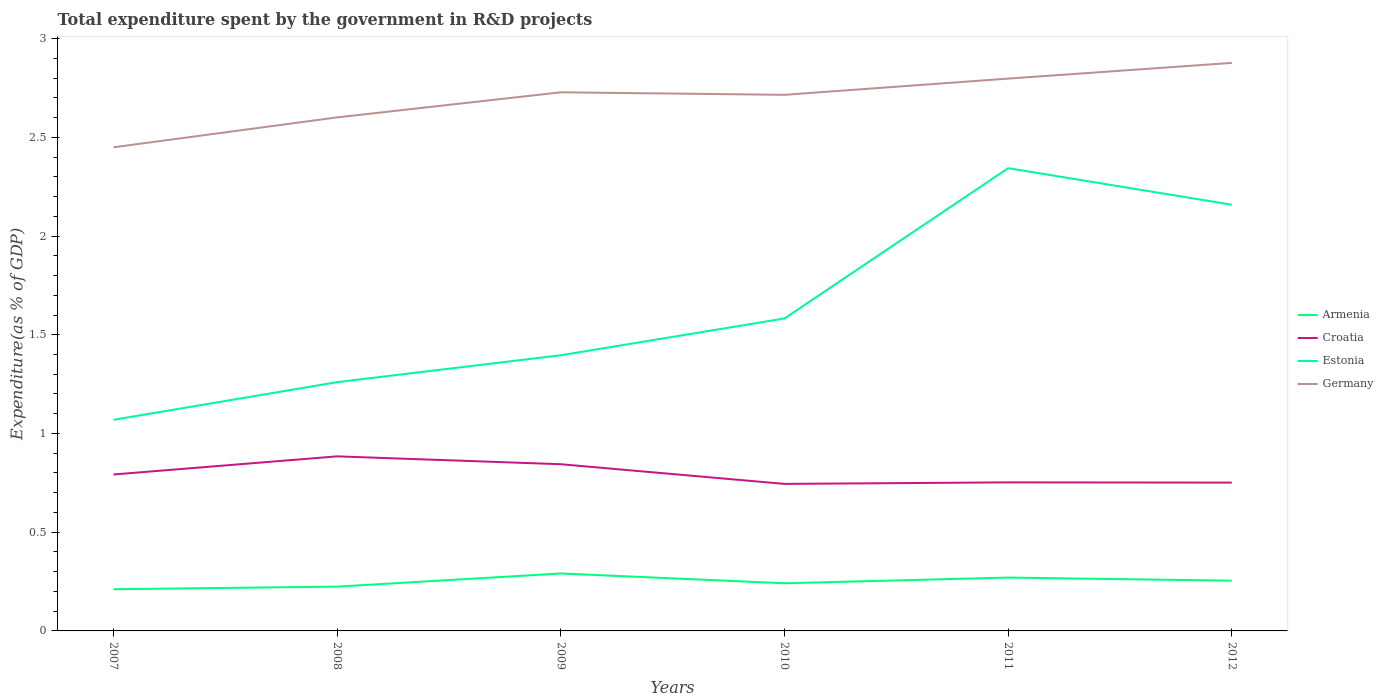Across all years, what is the maximum total expenditure spent by the government in R&D projects in Germany?
Make the answer very short. 2.45. What is the total total expenditure spent by the government in R&D projects in Croatia in the graph?
Your response must be concise. 0.04. What is the difference between the highest and the second highest total expenditure spent by the government in R&D projects in Germany?
Your answer should be very brief. 0.43. What is the difference between the highest and the lowest total expenditure spent by the government in R&D projects in Estonia?
Your answer should be very brief. 2. Is the total expenditure spent by the government in R&D projects in Germany strictly greater than the total expenditure spent by the government in R&D projects in Croatia over the years?
Give a very brief answer. No. How many lines are there?
Ensure brevity in your answer.  4. How many years are there in the graph?
Give a very brief answer. 6. Does the graph contain any zero values?
Your response must be concise. No. How many legend labels are there?
Offer a terse response. 4. How are the legend labels stacked?
Keep it short and to the point. Vertical. What is the title of the graph?
Offer a very short reply. Total expenditure spent by the government in R&D projects. Does "Palau" appear as one of the legend labels in the graph?
Provide a succinct answer. No. What is the label or title of the X-axis?
Make the answer very short. Years. What is the label or title of the Y-axis?
Provide a succinct answer. Expenditure(as % of GDP). What is the Expenditure(as % of GDP) of Armenia in 2007?
Your answer should be compact. 0.21. What is the Expenditure(as % of GDP) of Croatia in 2007?
Provide a short and direct response. 0.79. What is the Expenditure(as % of GDP) in Estonia in 2007?
Provide a succinct answer. 1.07. What is the Expenditure(as % of GDP) in Germany in 2007?
Your answer should be very brief. 2.45. What is the Expenditure(as % of GDP) of Armenia in 2008?
Ensure brevity in your answer.  0.22. What is the Expenditure(as % of GDP) of Croatia in 2008?
Make the answer very short. 0.88. What is the Expenditure(as % of GDP) of Estonia in 2008?
Your response must be concise. 1.26. What is the Expenditure(as % of GDP) of Germany in 2008?
Give a very brief answer. 2.6. What is the Expenditure(as % of GDP) in Armenia in 2009?
Your response must be concise. 0.29. What is the Expenditure(as % of GDP) of Croatia in 2009?
Your response must be concise. 0.84. What is the Expenditure(as % of GDP) of Estonia in 2009?
Provide a short and direct response. 1.4. What is the Expenditure(as % of GDP) in Germany in 2009?
Offer a terse response. 2.73. What is the Expenditure(as % of GDP) in Armenia in 2010?
Offer a terse response. 0.24. What is the Expenditure(as % of GDP) in Croatia in 2010?
Your response must be concise. 0.74. What is the Expenditure(as % of GDP) of Estonia in 2010?
Offer a very short reply. 1.58. What is the Expenditure(as % of GDP) in Germany in 2010?
Keep it short and to the point. 2.72. What is the Expenditure(as % of GDP) of Armenia in 2011?
Ensure brevity in your answer.  0.27. What is the Expenditure(as % of GDP) in Croatia in 2011?
Your answer should be very brief. 0.75. What is the Expenditure(as % of GDP) in Estonia in 2011?
Your answer should be compact. 2.34. What is the Expenditure(as % of GDP) of Germany in 2011?
Your answer should be compact. 2.8. What is the Expenditure(as % of GDP) of Armenia in 2012?
Your answer should be compact. 0.25. What is the Expenditure(as % of GDP) of Croatia in 2012?
Ensure brevity in your answer.  0.75. What is the Expenditure(as % of GDP) of Estonia in 2012?
Your answer should be compact. 2.16. What is the Expenditure(as % of GDP) of Germany in 2012?
Keep it short and to the point. 2.88. Across all years, what is the maximum Expenditure(as % of GDP) of Armenia?
Your response must be concise. 0.29. Across all years, what is the maximum Expenditure(as % of GDP) of Croatia?
Your answer should be very brief. 0.88. Across all years, what is the maximum Expenditure(as % of GDP) in Estonia?
Offer a terse response. 2.34. Across all years, what is the maximum Expenditure(as % of GDP) of Germany?
Ensure brevity in your answer.  2.88. Across all years, what is the minimum Expenditure(as % of GDP) of Armenia?
Provide a short and direct response. 0.21. Across all years, what is the minimum Expenditure(as % of GDP) of Croatia?
Provide a succinct answer. 0.74. Across all years, what is the minimum Expenditure(as % of GDP) in Estonia?
Provide a succinct answer. 1.07. Across all years, what is the minimum Expenditure(as % of GDP) of Germany?
Provide a succinct answer. 2.45. What is the total Expenditure(as % of GDP) of Armenia in the graph?
Provide a short and direct response. 1.49. What is the total Expenditure(as % of GDP) in Croatia in the graph?
Your answer should be very brief. 4.77. What is the total Expenditure(as % of GDP) in Estonia in the graph?
Provide a short and direct response. 9.81. What is the total Expenditure(as % of GDP) of Germany in the graph?
Provide a short and direct response. 16.17. What is the difference between the Expenditure(as % of GDP) in Armenia in 2007 and that in 2008?
Offer a very short reply. -0.01. What is the difference between the Expenditure(as % of GDP) of Croatia in 2007 and that in 2008?
Make the answer very short. -0.09. What is the difference between the Expenditure(as % of GDP) of Estonia in 2007 and that in 2008?
Provide a succinct answer. -0.19. What is the difference between the Expenditure(as % of GDP) of Germany in 2007 and that in 2008?
Your answer should be very brief. -0.15. What is the difference between the Expenditure(as % of GDP) in Armenia in 2007 and that in 2009?
Offer a very short reply. -0.08. What is the difference between the Expenditure(as % of GDP) in Croatia in 2007 and that in 2009?
Offer a terse response. -0.05. What is the difference between the Expenditure(as % of GDP) in Estonia in 2007 and that in 2009?
Provide a succinct answer. -0.33. What is the difference between the Expenditure(as % of GDP) in Germany in 2007 and that in 2009?
Offer a very short reply. -0.28. What is the difference between the Expenditure(as % of GDP) of Armenia in 2007 and that in 2010?
Provide a short and direct response. -0.03. What is the difference between the Expenditure(as % of GDP) of Croatia in 2007 and that in 2010?
Your answer should be compact. 0.05. What is the difference between the Expenditure(as % of GDP) of Estonia in 2007 and that in 2010?
Offer a terse response. -0.51. What is the difference between the Expenditure(as % of GDP) in Germany in 2007 and that in 2010?
Your answer should be compact. -0.27. What is the difference between the Expenditure(as % of GDP) in Armenia in 2007 and that in 2011?
Give a very brief answer. -0.06. What is the difference between the Expenditure(as % of GDP) in Croatia in 2007 and that in 2011?
Your answer should be very brief. 0.04. What is the difference between the Expenditure(as % of GDP) in Estonia in 2007 and that in 2011?
Provide a succinct answer. -1.27. What is the difference between the Expenditure(as % of GDP) of Germany in 2007 and that in 2011?
Your answer should be compact. -0.35. What is the difference between the Expenditure(as % of GDP) of Armenia in 2007 and that in 2012?
Your response must be concise. -0.04. What is the difference between the Expenditure(as % of GDP) of Croatia in 2007 and that in 2012?
Make the answer very short. 0.04. What is the difference between the Expenditure(as % of GDP) of Estonia in 2007 and that in 2012?
Make the answer very short. -1.09. What is the difference between the Expenditure(as % of GDP) in Germany in 2007 and that in 2012?
Your answer should be compact. -0.43. What is the difference between the Expenditure(as % of GDP) in Armenia in 2008 and that in 2009?
Offer a terse response. -0.07. What is the difference between the Expenditure(as % of GDP) in Croatia in 2008 and that in 2009?
Keep it short and to the point. 0.04. What is the difference between the Expenditure(as % of GDP) in Estonia in 2008 and that in 2009?
Provide a short and direct response. -0.14. What is the difference between the Expenditure(as % of GDP) in Germany in 2008 and that in 2009?
Give a very brief answer. -0.13. What is the difference between the Expenditure(as % of GDP) in Armenia in 2008 and that in 2010?
Give a very brief answer. -0.02. What is the difference between the Expenditure(as % of GDP) in Croatia in 2008 and that in 2010?
Provide a succinct answer. 0.14. What is the difference between the Expenditure(as % of GDP) of Estonia in 2008 and that in 2010?
Provide a short and direct response. -0.32. What is the difference between the Expenditure(as % of GDP) in Germany in 2008 and that in 2010?
Provide a short and direct response. -0.11. What is the difference between the Expenditure(as % of GDP) of Armenia in 2008 and that in 2011?
Your answer should be compact. -0.05. What is the difference between the Expenditure(as % of GDP) in Croatia in 2008 and that in 2011?
Keep it short and to the point. 0.13. What is the difference between the Expenditure(as % of GDP) in Estonia in 2008 and that in 2011?
Give a very brief answer. -1.08. What is the difference between the Expenditure(as % of GDP) in Germany in 2008 and that in 2011?
Your answer should be very brief. -0.2. What is the difference between the Expenditure(as % of GDP) in Armenia in 2008 and that in 2012?
Offer a very short reply. -0.03. What is the difference between the Expenditure(as % of GDP) of Croatia in 2008 and that in 2012?
Provide a short and direct response. 0.13. What is the difference between the Expenditure(as % of GDP) in Estonia in 2008 and that in 2012?
Give a very brief answer. -0.9. What is the difference between the Expenditure(as % of GDP) in Germany in 2008 and that in 2012?
Your answer should be very brief. -0.28. What is the difference between the Expenditure(as % of GDP) in Armenia in 2009 and that in 2010?
Provide a succinct answer. 0.05. What is the difference between the Expenditure(as % of GDP) in Croatia in 2009 and that in 2010?
Make the answer very short. 0.1. What is the difference between the Expenditure(as % of GDP) of Estonia in 2009 and that in 2010?
Make the answer very short. -0.19. What is the difference between the Expenditure(as % of GDP) of Germany in 2009 and that in 2010?
Give a very brief answer. 0.01. What is the difference between the Expenditure(as % of GDP) of Armenia in 2009 and that in 2011?
Your answer should be compact. 0.02. What is the difference between the Expenditure(as % of GDP) in Croatia in 2009 and that in 2011?
Offer a very short reply. 0.09. What is the difference between the Expenditure(as % of GDP) in Estonia in 2009 and that in 2011?
Your answer should be very brief. -0.95. What is the difference between the Expenditure(as % of GDP) in Germany in 2009 and that in 2011?
Your answer should be compact. -0.07. What is the difference between the Expenditure(as % of GDP) in Armenia in 2009 and that in 2012?
Provide a short and direct response. 0.04. What is the difference between the Expenditure(as % of GDP) in Croatia in 2009 and that in 2012?
Your answer should be compact. 0.09. What is the difference between the Expenditure(as % of GDP) in Estonia in 2009 and that in 2012?
Offer a very short reply. -0.76. What is the difference between the Expenditure(as % of GDP) in Germany in 2009 and that in 2012?
Make the answer very short. -0.15. What is the difference between the Expenditure(as % of GDP) of Armenia in 2010 and that in 2011?
Give a very brief answer. -0.03. What is the difference between the Expenditure(as % of GDP) of Croatia in 2010 and that in 2011?
Provide a short and direct response. -0.01. What is the difference between the Expenditure(as % of GDP) of Estonia in 2010 and that in 2011?
Your answer should be very brief. -0.76. What is the difference between the Expenditure(as % of GDP) of Germany in 2010 and that in 2011?
Offer a very short reply. -0.08. What is the difference between the Expenditure(as % of GDP) of Armenia in 2010 and that in 2012?
Provide a succinct answer. -0.01. What is the difference between the Expenditure(as % of GDP) in Croatia in 2010 and that in 2012?
Your answer should be very brief. -0.01. What is the difference between the Expenditure(as % of GDP) in Estonia in 2010 and that in 2012?
Provide a succinct answer. -0.58. What is the difference between the Expenditure(as % of GDP) of Germany in 2010 and that in 2012?
Keep it short and to the point. -0.16. What is the difference between the Expenditure(as % of GDP) of Armenia in 2011 and that in 2012?
Ensure brevity in your answer.  0.02. What is the difference between the Expenditure(as % of GDP) in Croatia in 2011 and that in 2012?
Keep it short and to the point. 0. What is the difference between the Expenditure(as % of GDP) in Estonia in 2011 and that in 2012?
Offer a very short reply. 0.19. What is the difference between the Expenditure(as % of GDP) of Germany in 2011 and that in 2012?
Your answer should be compact. -0.08. What is the difference between the Expenditure(as % of GDP) of Armenia in 2007 and the Expenditure(as % of GDP) of Croatia in 2008?
Make the answer very short. -0.67. What is the difference between the Expenditure(as % of GDP) in Armenia in 2007 and the Expenditure(as % of GDP) in Estonia in 2008?
Your response must be concise. -1.05. What is the difference between the Expenditure(as % of GDP) of Armenia in 2007 and the Expenditure(as % of GDP) of Germany in 2008?
Your answer should be very brief. -2.39. What is the difference between the Expenditure(as % of GDP) in Croatia in 2007 and the Expenditure(as % of GDP) in Estonia in 2008?
Offer a very short reply. -0.47. What is the difference between the Expenditure(as % of GDP) in Croatia in 2007 and the Expenditure(as % of GDP) in Germany in 2008?
Offer a very short reply. -1.81. What is the difference between the Expenditure(as % of GDP) in Estonia in 2007 and the Expenditure(as % of GDP) in Germany in 2008?
Your answer should be compact. -1.53. What is the difference between the Expenditure(as % of GDP) in Armenia in 2007 and the Expenditure(as % of GDP) in Croatia in 2009?
Offer a terse response. -0.63. What is the difference between the Expenditure(as % of GDP) in Armenia in 2007 and the Expenditure(as % of GDP) in Estonia in 2009?
Offer a very short reply. -1.19. What is the difference between the Expenditure(as % of GDP) of Armenia in 2007 and the Expenditure(as % of GDP) of Germany in 2009?
Provide a succinct answer. -2.52. What is the difference between the Expenditure(as % of GDP) in Croatia in 2007 and the Expenditure(as % of GDP) in Estonia in 2009?
Your response must be concise. -0.6. What is the difference between the Expenditure(as % of GDP) in Croatia in 2007 and the Expenditure(as % of GDP) in Germany in 2009?
Make the answer very short. -1.94. What is the difference between the Expenditure(as % of GDP) of Estonia in 2007 and the Expenditure(as % of GDP) of Germany in 2009?
Your answer should be very brief. -1.66. What is the difference between the Expenditure(as % of GDP) of Armenia in 2007 and the Expenditure(as % of GDP) of Croatia in 2010?
Your answer should be compact. -0.53. What is the difference between the Expenditure(as % of GDP) of Armenia in 2007 and the Expenditure(as % of GDP) of Estonia in 2010?
Your answer should be very brief. -1.37. What is the difference between the Expenditure(as % of GDP) in Armenia in 2007 and the Expenditure(as % of GDP) in Germany in 2010?
Make the answer very short. -2.5. What is the difference between the Expenditure(as % of GDP) in Croatia in 2007 and the Expenditure(as % of GDP) in Estonia in 2010?
Your answer should be compact. -0.79. What is the difference between the Expenditure(as % of GDP) in Croatia in 2007 and the Expenditure(as % of GDP) in Germany in 2010?
Your answer should be very brief. -1.92. What is the difference between the Expenditure(as % of GDP) of Estonia in 2007 and the Expenditure(as % of GDP) of Germany in 2010?
Offer a very short reply. -1.65. What is the difference between the Expenditure(as % of GDP) of Armenia in 2007 and the Expenditure(as % of GDP) of Croatia in 2011?
Provide a succinct answer. -0.54. What is the difference between the Expenditure(as % of GDP) in Armenia in 2007 and the Expenditure(as % of GDP) in Estonia in 2011?
Your answer should be compact. -2.13. What is the difference between the Expenditure(as % of GDP) of Armenia in 2007 and the Expenditure(as % of GDP) of Germany in 2011?
Your response must be concise. -2.59. What is the difference between the Expenditure(as % of GDP) in Croatia in 2007 and the Expenditure(as % of GDP) in Estonia in 2011?
Give a very brief answer. -1.55. What is the difference between the Expenditure(as % of GDP) in Croatia in 2007 and the Expenditure(as % of GDP) in Germany in 2011?
Provide a short and direct response. -2. What is the difference between the Expenditure(as % of GDP) in Estonia in 2007 and the Expenditure(as % of GDP) in Germany in 2011?
Offer a terse response. -1.73. What is the difference between the Expenditure(as % of GDP) in Armenia in 2007 and the Expenditure(as % of GDP) in Croatia in 2012?
Your answer should be compact. -0.54. What is the difference between the Expenditure(as % of GDP) in Armenia in 2007 and the Expenditure(as % of GDP) in Estonia in 2012?
Give a very brief answer. -1.95. What is the difference between the Expenditure(as % of GDP) in Armenia in 2007 and the Expenditure(as % of GDP) in Germany in 2012?
Give a very brief answer. -2.67. What is the difference between the Expenditure(as % of GDP) of Croatia in 2007 and the Expenditure(as % of GDP) of Estonia in 2012?
Your response must be concise. -1.37. What is the difference between the Expenditure(as % of GDP) in Croatia in 2007 and the Expenditure(as % of GDP) in Germany in 2012?
Keep it short and to the point. -2.08. What is the difference between the Expenditure(as % of GDP) in Estonia in 2007 and the Expenditure(as % of GDP) in Germany in 2012?
Offer a very short reply. -1.81. What is the difference between the Expenditure(as % of GDP) of Armenia in 2008 and the Expenditure(as % of GDP) of Croatia in 2009?
Keep it short and to the point. -0.62. What is the difference between the Expenditure(as % of GDP) of Armenia in 2008 and the Expenditure(as % of GDP) of Estonia in 2009?
Keep it short and to the point. -1.17. What is the difference between the Expenditure(as % of GDP) in Armenia in 2008 and the Expenditure(as % of GDP) in Germany in 2009?
Offer a terse response. -2.5. What is the difference between the Expenditure(as % of GDP) in Croatia in 2008 and the Expenditure(as % of GDP) in Estonia in 2009?
Provide a short and direct response. -0.51. What is the difference between the Expenditure(as % of GDP) in Croatia in 2008 and the Expenditure(as % of GDP) in Germany in 2009?
Make the answer very short. -1.84. What is the difference between the Expenditure(as % of GDP) in Estonia in 2008 and the Expenditure(as % of GDP) in Germany in 2009?
Your answer should be very brief. -1.47. What is the difference between the Expenditure(as % of GDP) in Armenia in 2008 and the Expenditure(as % of GDP) in Croatia in 2010?
Offer a very short reply. -0.52. What is the difference between the Expenditure(as % of GDP) of Armenia in 2008 and the Expenditure(as % of GDP) of Estonia in 2010?
Give a very brief answer. -1.36. What is the difference between the Expenditure(as % of GDP) of Armenia in 2008 and the Expenditure(as % of GDP) of Germany in 2010?
Keep it short and to the point. -2.49. What is the difference between the Expenditure(as % of GDP) in Croatia in 2008 and the Expenditure(as % of GDP) in Estonia in 2010?
Ensure brevity in your answer.  -0.7. What is the difference between the Expenditure(as % of GDP) of Croatia in 2008 and the Expenditure(as % of GDP) of Germany in 2010?
Ensure brevity in your answer.  -1.83. What is the difference between the Expenditure(as % of GDP) in Estonia in 2008 and the Expenditure(as % of GDP) in Germany in 2010?
Ensure brevity in your answer.  -1.46. What is the difference between the Expenditure(as % of GDP) in Armenia in 2008 and the Expenditure(as % of GDP) in Croatia in 2011?
Offer a terse response. -0.53. What is the difference between the Expenditure(as % of GDP) in Armenia in 2008 and the Expenditure(as % of GDP) in Estonia in 2011?
Keep it short and to the point. -2.12. What is the difference between the Expenditure(as % of GDP) in Armenia in 2008 and the Expenditure(as % of GDP) in Germany in 2011?
Make the answer very short. -2.57. What is the difference between the Expenditure(as % of GDP) of Croatia in 2008 and the Expenditure(as % of GDP) of Estonia in 2011?
Offer a very short reply. -1.46. What is the difference between the Expenditure(as % of GDP) of Croatia in 2008 and the Expenditure(as % of GDP) of Germany in 2011?
Your response must be concise. -1.91. What is the difference between the Expenditure(as % of GDP) in Estonia in 2008 and the Expenditure(as % of GDP) in Germany in 2011?
Offer a terse response. -1.54. What is the difference between the Expenditure(as % of GDP) in Armenia in 2008 and the Expenditure(as % of GDP) in Croatia in 2012?
Provide a succinct answer. -0.53. What is the difference between the Expenditure(as % of GDP) of Armenia in 2008 and the Expenditure(as % of GDP) of Estonia in 2012?
Your response must be concise. -1.93. What is the difference between the Expenditure(as % of GDP) in Armenia in 2008 and the Expenditure(as % of GDP) in Germany in 2012?
Ensure brevity in your answer.  -2.65. What is the difference between the Expenditure(as % of GDP) in Croatia in 2008 and the Expenditure(as % of GDP) in Estonia in 2012?
Make the answer very short. -1.27. What is the difference between the Expenditure(as % of GDP) of Croatia in 2008 and the Expenditure(as % of GDP) of Germany in 2012?
Offer a terse response. -1.99. What is the difference between the Expenditure(as % of GDP) in Estonia in 2008 and the Expenditure(as % of GDP) in Germany in 2012?
Provide a short and direct response. -1.62. What is the difference between the Expenditure(as % of GDP) of Armenia in 2009 and the Expenditure(as % of GDP) of Croatia in 2010?
Provide a short and direct response. -0.45. What is the difference between the Expenditure(as % of GDP) in Armenia in 2009 and the Expenditure(as % of GDP) in Estonia in 2010?
Keep it short and to the point. -1.29. What is the difference between the Expenditure(as % of GDP) of Armenia in 2009 and the Expenditure(as % of GDP) of Germany in 2010?
Provide a succinct answer. -2.42. What is the difference between the Expenditure(as % of GDP) in Croatia in 2009 and the Expenditure(as % of GDP) in Estonia in 2010?
Your answer should be compact. -0.74. What is the difference between the Expenditure(as % of GDP) of Croatia in 2009 and the Expenditure(as % of GDP) of Germany in 2010?
Your answer should be compact. -1.87. What is the difference between the Expenditure(as % of GDP) of Estonia in 2009 and the Expenditure(as % of GDP) of Germany in 2010?
Offer a terse response. -1.32. What is the difference between the Expenditure(as % of GDP) of Armenia in 2009 and the Expenditure(as % of GDP) of Croatia in 2011?
Provide a short and direct response. -0.46. What is the difference between the Expenditure(as % of GDP) in Armenia in 2009 and the Expenditure(as % of GDP) in Estonia in 2011?
Make the answer very short. -2.05. What is the difference between the Expenditure(as % of GDP) in Armenia in 2009 and the Expenditure(as % of GDP) in Germany in 2011?
Make the answer very short. -2.51. What is the difference between the Expenditure(as % of GDP) in Croatia in 2009 and the Expenditure(as % of GDP) in Estonia in 2011?
Ensure brevity in your answer.  -1.5. What is the difference between the Expenditure(as % of GDP) in Croatia in 2009 and the Expenditure(as % of GDP) in Germany in 2011?
Your answer should be compact. -1.95. What is the difference between the Expenditure(as % of GDP) in Estonia in 2009 and the Expenditure(as % of GDP) in Germany in 2011?
Make the answer very short. -1.4. What is the difference between the Expenditure(as % of GDP) in Armenia in 2009 and the Expenditure(as % of GDP) in Croatia in 2012?
Offer a very short reply. -0.46. What is the difference between the Expenditure(as % of GDP) in Armenia in 2009 and the Expenditure(as % of GDP) in Estonia in 2012?
Give a very brief answer. -1.87. What is the difference between the Expenditure(as % of GDP) in Armenia in 2009 and the Expenditure(as % of GDP) in Germany in 2012?
Your answer should be very brief. -2.59. What is the difference between the Expenditure(as % of GDP) in Croatia in 2009 and the Expenditure(as % of GDP) in Estonia in 2012?
Make the answer very short. -1.31. What is the difference between the Expenditure(as % of GDP) in Croatia in 2009 and the Expenditure(as % of GDP) in Germany in 2012?
Your answer should be very brief. -2.03. What is the difference between the Expenditure(as % of GDP) in Estonia in 2009 and the Expenditure(as % of GDP) in Germany in 2012?
Your answer should be very brief. -1.48. What is the difference between the Expenditure(as % of GDP) of Armenia in 2010 and the Expenditure(as % of GDP) of Croatia in 2011?
Your answer should be compact. -0.51. What is the difference between the Expenditure(as % of GDP) of Armenia in 2010 and the Expenditure(as % of GDP) of Estonia in 2011?
Make the answer very short. -2.1. What is the difference between the Expenditure(as % of GDP) in Armenia in 2010 and the Expenditure(as % of GDP) in Germany in 2011?
Keep it short and to the point. -2.56. What is the difference between the Expenditure(as % of GDP) of Croatia in 2010 and the Expenditure(as % of GDP) of Estonia in 2011?
Make the answer very short. -1.6. What is the difference between the Expenditure(as % of GDP) of Croatia in 2010 and the Expenditure(as % of GDP) of Germany in 2011?
Provide a succinct answer. -2.05. What is the difference between the Expenditure(as % of GDP) in Estonia in 2010 and the Expenditure(as % of GDP) in Germany in 2011?
Ensure brevity in your answer.  -1.21. What is the difference between the Expenditure(as % of GDP) of Armenia in 2010 and the Expenditure(as % of GDP) of Croatia in 2012?
Your answer should be compact. -0.51. What is the difference between the Expenditure(as % of GDP) of Armenia in 2010 and the Expenditure(as % of GDP) of Estonia in 2012?
Provide a short and direct response. -1.92. What is the difference between the Expenditure(as % of GDP) of Armenia in 2010 and the Expenditure(as % of GDP) of Germany in 2012?
Give a very brief answer. -2.64. What is the difference between the Expenditure(as % of GDP) in Croatia in 2010 and the Expenditure(as % of GDP) in Estonia in 2012?
Your answer should be compact. -1.41. What is the difference between the Expenditure(as % of GDP) of Croatia in 2010 and the Expenditure(as % of GDP) of Germany in 2012?
Make the answer very short. -2.13. What is the difference between the Expenditure(as % of GDP) of Estonia in 2010 and the Expenditure(as % of GDP) of Germany in 2012?
Your response must be concise. -1.29. What is the difference between the Expenditure(as % of GDP) in Armenia in 2011 and the Expenditure(as % of GDP) in Croatia in 2012?
Offer a very short reply. -0.48. What is the difference between the Expenditure(as % of GDP) in Armenia in 2011 and the Expenditure(as % of GDP) in Estonia in 2012?
Give a very brief answer. -1.89. What is the difference between the Expenditure(as % of GDP) in Armenia in 2011 and the Expenditure(as % of GDP) in Germany in 2012?
Make the answer very short. -2.61. What is the difference between the Expenditure(as % of GDP) of Croatia in 2011 and the Expenditure(as % of GDP) of Estonia in 2012?
Your answer should be very brief. -1.41. What is the difference between the Expenditure(as % of GDP) in Croatia in 2011 and the Expenditure(as % of GDP) in Germany in 2012?
Offer a terse response. -2.12. What is the difference between the Expenditure(as % of GDP) in Estonia in 2011 and the Expenditure(as % of GDP) in Germany in 2012?
Give a very brief answer. -0.53. What is the average Expenditure(as % of GDP) in Armenia per year?
Keep it short and to the point. 0.25. What is the average Expenditure(as % of GDP) in Croatia per year?
Ensure brevity in your answer.  0.79. What is the average Expenditure(as % of GDP) of Estonia per year?
Your answer should be compact. 1.64. What is the average Expenditure(as % of GDP) of Germany per year?
Provide a succinct answer. 2.69. In the year 2007, what is the difference between the Expenditure(as % of GDP) in Armenia and Expenditure(as % of GDP) in Croatia?
Your answer should be very brief. -0.58. In the year 2007, what is the difference between the Expenditure(as % of GDP) in Armenia and Expenditure(as % of GDP) in Estonia?
Make the answer very short. -0.86. In the year 2007, what is the difference between the Expenditure(as % of GDP) of Armenia and Expenditure(as % of GDP) of Germany?
Ensure brevity in your answer.  -2.24. In the year 2007, what is the difference between the Expenditure(as % of GDP) in Croatia and Expenditure(as % of GDP) in Estonia?
Your response must be concise. -0.28. In the year 2007, what is the difference between the Expenditure(as % of GDP) of Croatia and Expenditure(as % of GDP) of Germany?
Your answer should be very brief. -1.66. In the year 2007, what is the difference between the Expenditure(as % of GDP) of Estonia and Expenditure(as % of GDP) of Germany?
Your answer should be very brief. -1.38. In the year 2008, what is the difference between the Expenditure(as % of GDP) of Armenia and Expenditure(as % of GDP) of Croatia?
Ensure brevity in your answer.  -0.66. In the year 2008, what is the difference between the Expenditure(as % of GDP) in Armenia and Expenditure(as % of GDP) in Estonia?
Ensure brevity in your answer.  -1.04. In the year 2008, what is the difference between the Expenditure(as % of GDP) of Armenia and Expenditure(as % of GDP) of Germany?
Your response must be concise. -2.38. In the year 2008, what is the difference between the Expenditure(as % of GDP) in Croatia and Expenditure(as % of GDP) in Estonia?
Make the answer very short. -0.38. In the year 2008, what is the difference between the Expenditure(as % of GDP) in Croatia and Expenditure(as % of GDP) in Germany?
Your answer should be very brief. -1.72. In the year 2008, what is the difference between the Expenditure(as % of GDP) of Estonia and Expenditure(as % of GDP) of Germany?
Your answer should be compact. -1.34. In the year 2009, what is the difference between the Expenditure(as % of GDP) in Armenia and Expenditure(as % of GDP) in Croatia?
Your response must be concise. -0.55. In the year 2009, what is the difference between the Expenditure(as % of GDP) of Armenia and Expenditure(as % of GDP) of Estonia?
Give a very brief answer. -1.11. In the year 2009, what is the difference between the Expenditure(as % of GDP) in Armenia and Expenditure(as % of GDP) in Germany?
Offer a terse response. -2.44. In the year 2009, what is the difference between the Expenditure(as % of GDP) in Croatia and Expenditure(as % of GDP) in Estonia?
Ensure brevity in your answer.  -0.55. In the year 2009, what is the difference between the Expenditure(as % of GDP) in Croatia and Expenditure(as % of GDP) in Germany?
Keep it short and to the point. -1.88. In the year 2009, what is the difference between the Expenditure(as % of GDP) of Estonia and Expenditure(as % of GDP) of Germany?
Provide a succinct answer. -1.33. In the year 2010, what is the difference between the Expenditure(as % of GDP) of Armenia and Expenditure(as % of GDP) of Croatia?
Ensure brevity in your answer.  -0.5. In the year 2010, what is the difference between the Expenditure(as % of GDP) of Armenia and Expenditure(as % of GDP) of Estonia?
Give a very brief answer. -1.34. In the year 2010, what is the difference between the Expenditure(as % of GDP) in Armenia and Expenditure(as % of GDP) in Germany?
Your answer should be compact. -2.47. In the year 2010, what is the difference between the Expenditure(as % of GDP) of Croatia and Expenditure(as % of GDP) of Estonia?
Keep it short and to the point. -0.84. In the year 2010, what is the difference between the Expenditure(as % of GDP) of Croatia and Expenditure(as % of GDP) of Germany?
Keep it short and to the point. -1.97. In the year 2010, what is the difference between the Expenditure(as % of GDP) in Estonia and Expenditure(as % of GDP) in Germany?
Give a very brief answer. -1.13. In the year 2011, what is the difference between the Expenditure(as % of GDP) of Armenia and Expenditure(as % of GDP) of Croatia?
Your answer should be compact. -0.48. In the year 2011, what is the difference between the Expenditure(as % of GDP) in Armenia and Expenditure(as % of GDP) in Estonia?
Your answer should be compact. -2.07. In the year 2011, what is the difference between the Expenditure(as % of GDP) of Armenia and Expenditure(as % of GDP) of Germany?
Your answer should be compact. -2.53. In the year 2011, what is the difference between the Expenditure(as % of GDP) of Croatia and Expenditure(as % of GDP) of Estonia?
Make the answer very short. -1.59. In the year 2011, what is the difference between the Expenditure(as % of GDP) in Croatia and Expenditure(as % of GDP) in Germany?
Give a very brief answer. -2.04. In the year 2011, what is the difference between the Expenditure(as % of GDP) of Estonia and Expenditure(as % of GDP) of Germany?
Keep it short and to the point. -0.45. In the year 2012, what is the difference between the Expenditure(as % of GDP) in Armenia and Expenditure(as % of GDP) in Croatia?
Ensure brevity in your answer.  -0.5. In the year 2012, what is the difference between the Expenditure(as % of GDP) of Armenia and Expenditure(as % of GDP) of Estonia?
Your response must be concise. -1.9. In the year 2012, what is the difference between the Expenditure(as % of GDP) of Armenia and Expenditure(as % of GDP) of Germany?
Offer a terse response. -2.62. In the year 2012, what is the difference between the Expenditure(as % of GDP) in Croatia and Expenditure(as % of GDP) in Estonia?
Your answer should be compact. -1.41. In the year 2012, what is the difference between the Expenditure(as % of GDP) in Croatia and Expenditure(as % of GDP) in Germany?
Offer a very short reply. -2.13. In the year 2012, what is the difference between the Expenditure(as % of GDP) in Estonia and Expenditure(as % of GDP) in Germany?
Offer a very short reply. -0.72. What is the ratio of the Expenditure(as % of GDP) of Armenia in 2007 to that in 2008?
Your answer should be very brief. 0.94. What is the ratio of the Expenditure(as % of GDP) of Croatia in 2007 to that in 2008?
Offer a terse response. 0.9. What is the ratio of the Expenditure(as % of GDP) in Estonia in 2007 to that in 2008?
Your response must be concise. 0.85. What is the ratio of the Expenditure(as % of GDP) in Germany in 2007 to that in 2008?
Provide a short and direct response. 0.94. What is the ratio of the Expenditure(as % of GDP) in Armenia in 2007 to that in 2009?
Provide a succinct answer. 0.73. What is the ratio of the Expenditure(as % of GDP) in Croatia in 2007 to that in 2009?
Provide a short and direct response. 0.94. What is the ratio of the Expenditure(as % of GDP) of Estonia in 2007 to that in 2009?
Offer a very short reply. 0.77. What is the ratio of the Expenditure(as % of GDP) of Germany in 2007 to that in 2009?
Provide a succinct answer. 0.9. What is the ratio of the Expenditure(as % of GDP) of Armenia in 2007 to that in 2010?
Offer a terse response. 0.87. What is the ratio of the Expenditure(as % of GDP) in Croatia in 2007 to that in 2010?
Offer a terse response. 1.06. What is the ratio of the Expenditure(as % of GDP) of Estonia in 2007 to that in 2010?
Give a very brief answer. 0.68. What is the ratio of the Expenditure(as % of GDP) of Germany in 2007 to that in 2010?
Provide a succinct answer. 0.9. What is the ratio of the Expenditure(as % of GDP) in Armenia in 2007 to that in 2011?
Make the answer very short. 0.78. What is the ratio of the Expenditure(as % of GDP) in Croatia in 2007 to that in 2011?
Offer a terse response. 1.05. What is the ratio of the Expenditure(as % of GDP) in Estonia in 2007 to that in 2011?
Make the answer very short. 0.46. What is the ratio of the Expenditure(as % of GDP) of Germany in 2007 to that in 2011?
Ensure brevity in your answer.  0.88. What is the ratio of the Expenditure(as % of GDP) in Armenia in 2007 to that in 2012?
Offer a very short reply. 0.83. What is the ratio of the Expenditure(as % of GDP) in Croatia in 2007 to that in 2012?
Make the answer very short. 1.05. What is the ratio of the Expenditure(as % of GDP) in Estonia in 2007 to that in 2012?
Provide a succinct answer. 0.5. What is the ratio of the Expenditure(as % of GDP) of Germany in 2007 to that in 2012?
Give a very brief answer. 0.85. What is the ratio of the Expenditure(as % of GDP) in Armenia in 2008 to that in 2009?
Provide a succinct answer. 0.77. What is the ratio of the Expenditure(as % of GDP) of Croatia in 2008 to that in 2009?
Ensure brevity in your answer.  1.05. What is the ratio of the Expenditure(as % of GDP) of Estonia in 2008 to that in 2009?
Offer a very short reply. 0.9. What is the ratio of the Expenditure(as % of GDP) in Germany in 2008 to that in 2009?
Provide a short and direct response. 0.95. What is the ratio of the Expenditure(as % of GDP) in Armenia in 2008 to that in 2010?
Your answer should be very brief. 0.93. What is the ratio of the Expenditure(as % of GDP) in Croatia in 2008 to that in 2010?
Provide a succinct answer. 1.19. What is the ratio of the Expenditure(as % of GDP) of Estonia in 2008 to that in 2010?
Provide a succinct answer. 0.8. What is the ratio of the Expenditure(as % of GDP) of Germany in 2008 to that in 2010?
Provide a short and direct response. 0.96. What is the ratio of the Expenditure(as % of GDP) in Armenia in 2008 to that in 2011?
Make the answer very short. 0.83. What is the ratio of the Expenditure(as % of GDP) of Croatia in 2008 to that in 2011?
Provide a succinct answer. 1.18. What is the ratio of the Expenditure(as % of GDP) of Estonia in 2008 to that in 2011?
Ensure brevity in your answer.  0.54. What is the ratio of the Expenditure(as % of GDP) in Germany in 2008 to that in 2011?
Your answer should be compact. 0.93. What is the ratio of the Expenditure(as % of GDP) of Armenia in 2008 to that in 2012?
Provide a short and direct response. 0.88. What is the ratio of the Expenditure(as % of GDP) of Croatia in 2008 to that in 2012?
Your answer should be compact. 1.18. What is the ratio of the Expenditure(as % of GDP) of Estonia in 2008 to that in 2012?
Ensure brevity in your answer.  0.58. What is the ratio of the Expenditure(as % of GDP) of Germany in 2008 to that in 2012?
Make the answer very short. 0.9. What is the ratio of the Expenditure(as % of GDP) in Armenia in 2009 to that in 2010?
Offer a terse response. 1.21. What is the ratio of the Expenditure(as % of GDP) of Croatia in 2009 to that in 2010?
Provide a short and direct response. 1.13. What is the ratio of the Expenditure(as % of GDP) in Estonia in 2009 to that in 2010?
Your response must be concise. 0.88. What is the ratio of the Expenditure(as % of GDP) of Armenia in 2009 to that in 2011?
Keep it short and to the point. 1.08. What is the ratio of the Expenditure(as % of GDP) of Croatia in 2009 to that in 2011?
Offer a very short reply. 1.12. What is the ratio of the Expenditure(as % of GDP) in Estonia in 2009 to that in 2011?
Your answer should be very brief. 0.6. What is the ratio of the Expenditure(as % of GDP) in Germany in 2009 to that in 2011?
Your answer should be very brief. 0.98. What is the ratio of the Expenditure(as % of GDP) of Armenia in 2009 to that in 2012?
Keep it short and to the point. 1.14. What is the ratio of the Expenditure(as % of GDP) in Croatia in 2009 to that in 2012?
Your answer should be very brief. 1.12. What is the ratio of the Expenditure(as % of GDP) of Estonia in 2009 to that in 2012?
Give a very brief answer. 0.65. What is the ratio of the Expenditure(as % of GDP) of Germany in 2009 to that in 2012?
Provide a short and direct response. 0.95. What is the ratio of the Expenditure(as % of GDP) in Armenia in 2010 to that in 2011?
Your response must be concise. 0.89. What is the ratio of the Expenditure(as % of GDP) in Estonia in 2010 to that in 2011?
Provide a short and direct response. 0.68. What is the ratio of the Expenditure(as % of GDP) in Germany in 2010 to that in 2011?
Make the answer very short. 0.97. What is the ratio of the Expenditure(as % of GDP) of Armenia in 2010 to that in 2012?
Offer a terse response. 0.95. What is the ratio of the Expenditure(as % of GDP) in Croatia in 2010 to that in 2012?
Make the answer very short. 0.99. What is the ratio of the Expenditure(as % of GDP) of Estonia in 2010 to that in 2012?
Your response must be concise. 0.73. What is the ratio of the Expenditure(as % of GDP) in Germany in 2010 to that in 2012?
Provide a succinct answer. 0.94. What is the ratio of the Expenditure(as % of GDP) in Armenia in 2011 to that in 2012?
Give a very brief answer. 1.06. What is the ratio of the Expenditure(as % of GDP) of Estonia in 2011 to that in 2012?
Make the answer very short. 1.09. What is the ratio of the Expenditure(as % of GDP) of Germany in 2011 to that in 2012?
Provide a short and direct response. 0.97. What is the difference between the highest and the second highest Expenditure(as % of GDP) in Armenia?
Offer a very short reply. 0.02. What is the difference between the highest and the second highest Expenditure(as % of GDP) of Croatia?
Your answer should be very brief. 0.04. What is the difference between the highest and the second highest Expenditure(as % of GDP) of Estonia?
Make the answer very short. 0.19. What is the difference between the highest and the second highest Expenditure(as % of GDP) of Germany?
Offer a very short reply. 0.08. What is the difference between the highest and the lowest Expenditure(as % of GDP) of Armenia?
Make the answer very short. 0.08. What is the difference between the highest and the lowest Expenditure(as % of GDP) of Croatia?
Provide a short and direct response. 0.14. What is the difference between the highest and the lowest Expenditure(as % of GDP) in Estonia?
Your answer should be very brief. 1.27. What is the difference between the highest and the lowest Expenditure(as % of GDP) of Germany?
Provide a succinct answer. 0.43. 